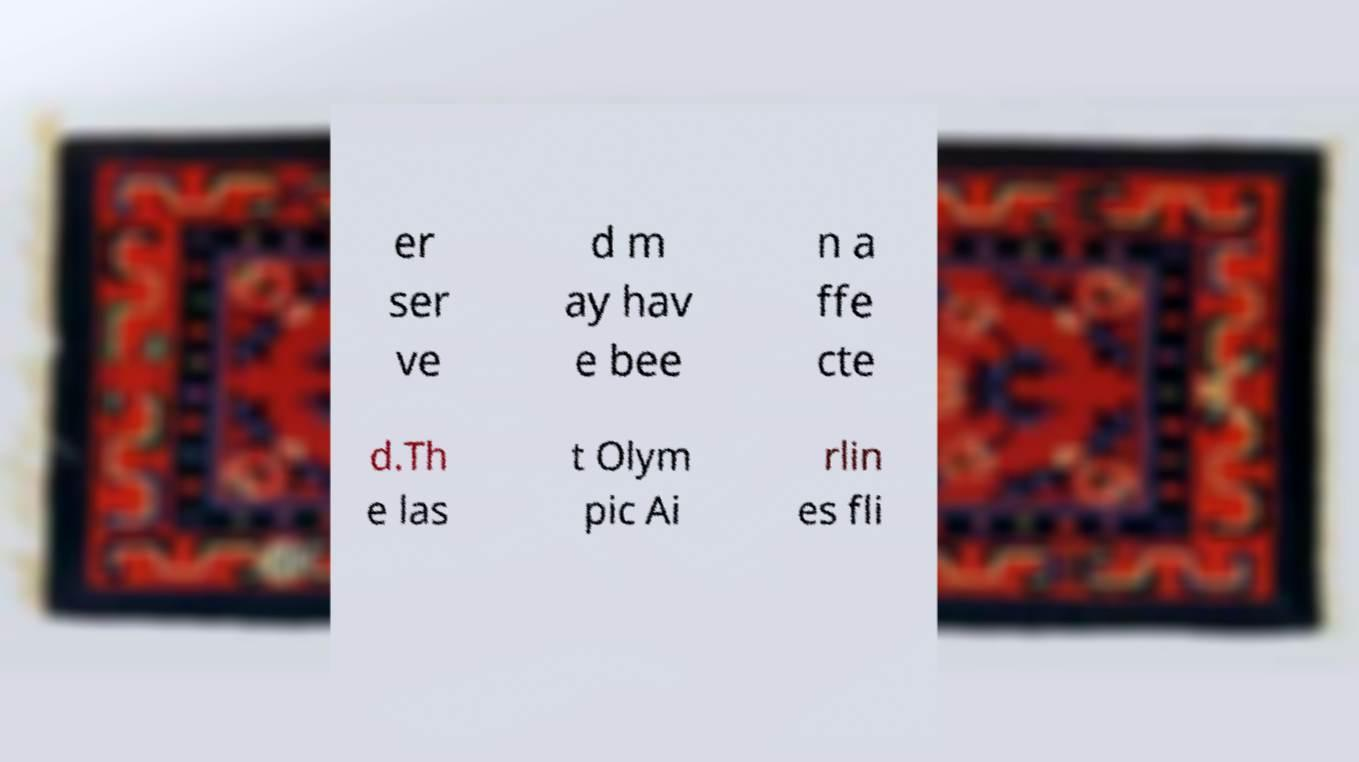I need the written content from this picture converted into text. Can you do that? er ser ve d m ay hav e bee n a ffe cte d.Th e las t Olym pic Ai rlin es fli 